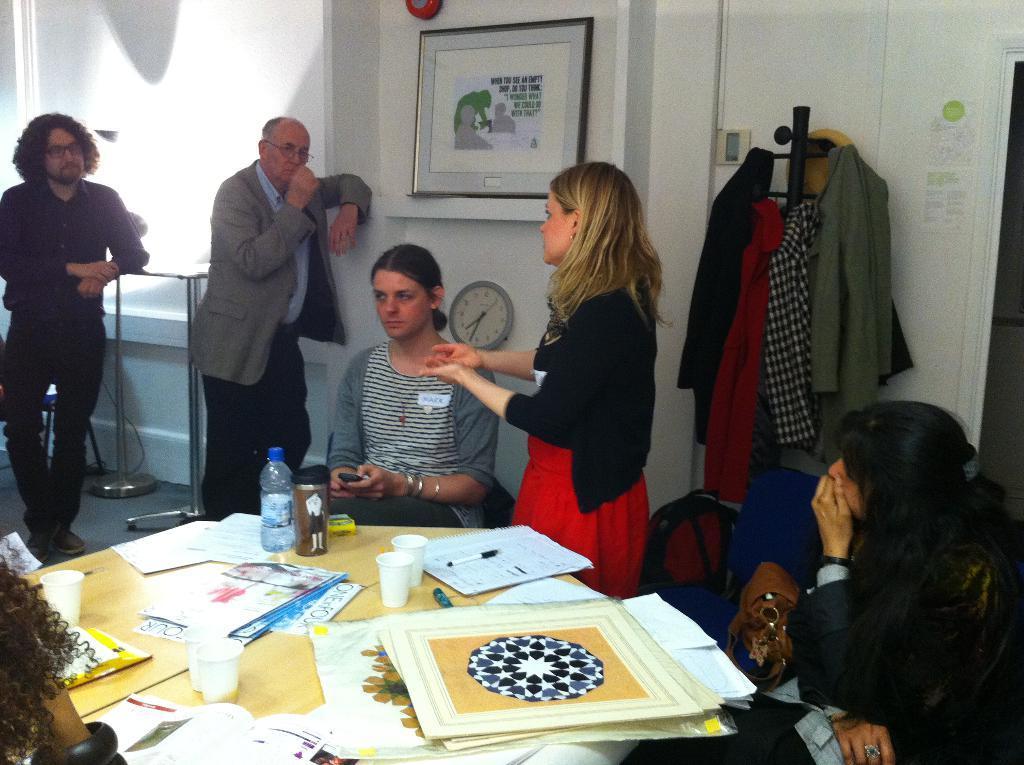Describe this image in one or two sentences. There are some people sitting and standing in front of a table which has papers and some other objects on it. 